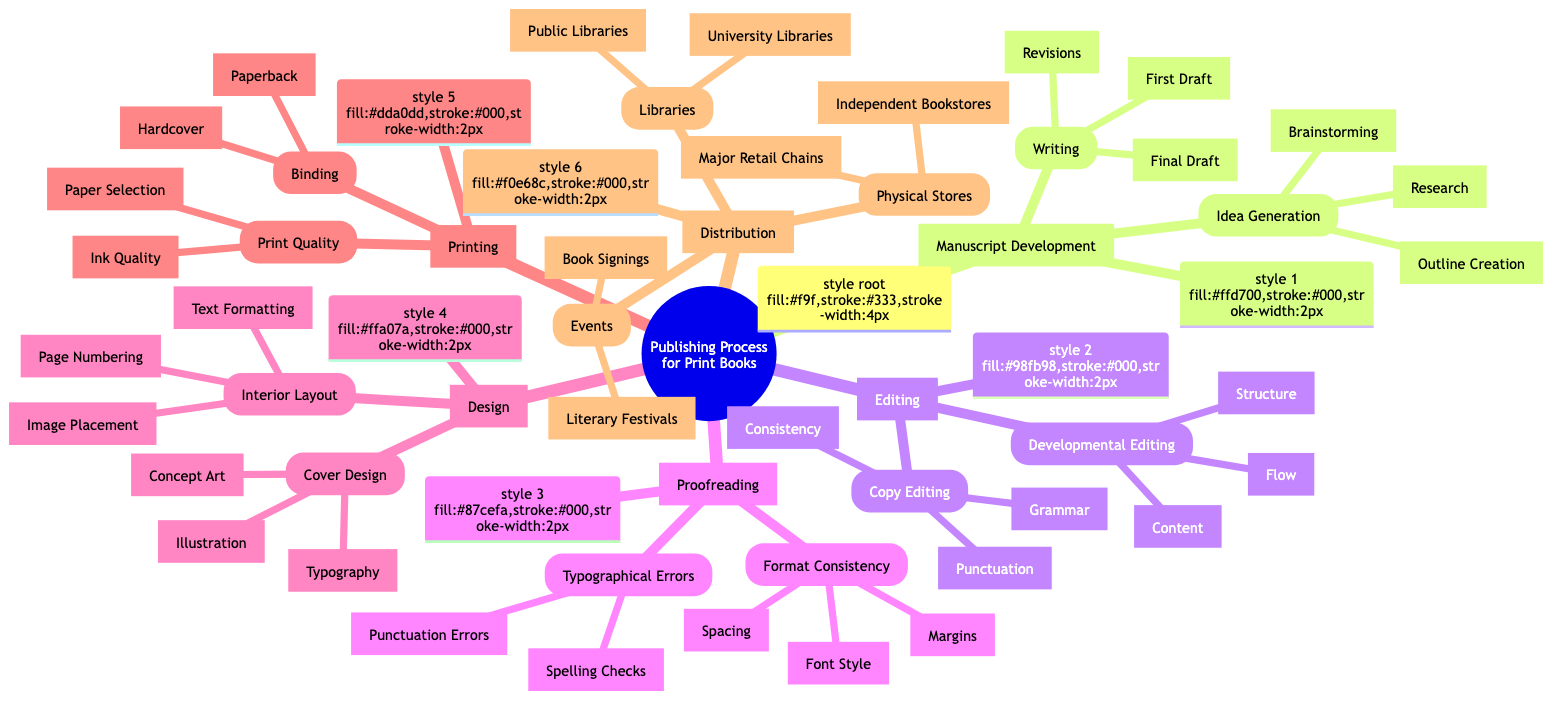What are the two main categories under "Editing"? The diagram outlines "Developmental Editing" and "Copy Editing" as the two primary categories under "Editing".
Answer: Developmental Editing, Copy Editing How many steps are listed under "Proofreading"? Under "Proofreading", there are two main components: "Typographical Errors" and "Format Consistency", each having its own detailed steps. Counting the steps provides a total of four steps: two for each component.
Answer: 4 What is listed first under "Design"? The first subcategory under "Design" is "Cover Design", which contains further components related to cover aesthetics.
Answer: Cover Design Which aspect of "Distribution" includes "Major Retail Chains"? The aspect of "Distribution" that includes "Major Retail Chains" falls under "Physical Stores" in the diagram, indicating this category covers various retail distributions.
Answer: Physical Stores What is the structure of the "Manuscript Development"? The "Manuscript Development" is divided into two main parts: "Idea Generation" and "Writing", with each having their respective steps detailed below them.
Answer: Idea Generation, Writing How many steps are in the "Cover Design" subcategory? The "Cover Design" subcategory includes three specific steps: "Concept Art", "Illustration", and "Typography".
Answer: 3 Which step in "Proofreading" relates to font adjustments? The step related to font adjustments within "Proofreading" is "Font Style", highlighting the focus on maintaining typographic consistency.
Answer: Font Style What type of binding options are available under "Printing"? Under "Printing", the binding options available are "Hardcover" and "Paperback", offering different formats for book construction.
Answer: Hardcover, Paperback What are the two types of libraries mentioned in "Distribution"? The diagram specifies "Public Libraries" and "University Libraries" as the two types of libraries involved in the distribution of print books.
Answer: Public Libraries, University Libraries 